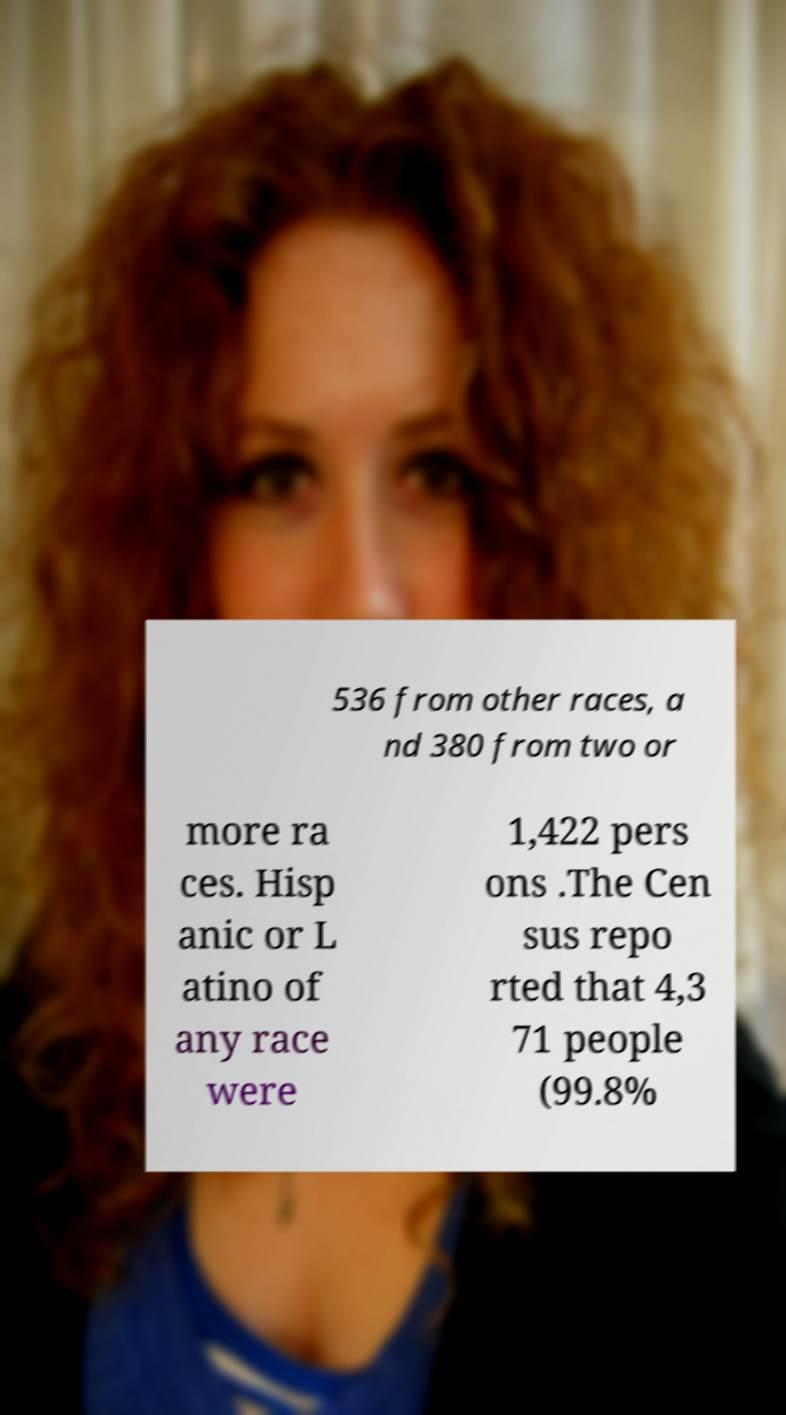Please read and relay the text visible in this image. What does it say? 536 from other races, a nd 380 from two or more ra ces. Hisp anic or L atino of any race were 1,422 pers ons .The Cen sus repo rted that 4,3 71 people (99.8% 